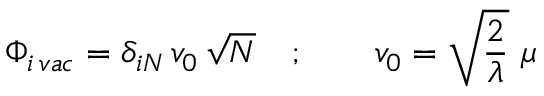Convert formula to latex. <formula><loc_0><loc_0><loc_500><loc_500>\Phi _ { i \, v a c } = \delta _ { i N } \, v _ { 0 } \, \sqrt { N } \quad ; \quad v _ { 0 } = \sqrt { { \frac { 2 } { \lambda } } } \ \mu</formula> 